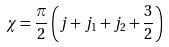Convert formula to latex. <formula><loc_0><loc_0><loc_500><loc_500>\chi = \frac { \pi } { 2 } \left ( j + j _ { 1 } + j _ { 2 } + \frac { 3 } { 2 } \right )</formula> 